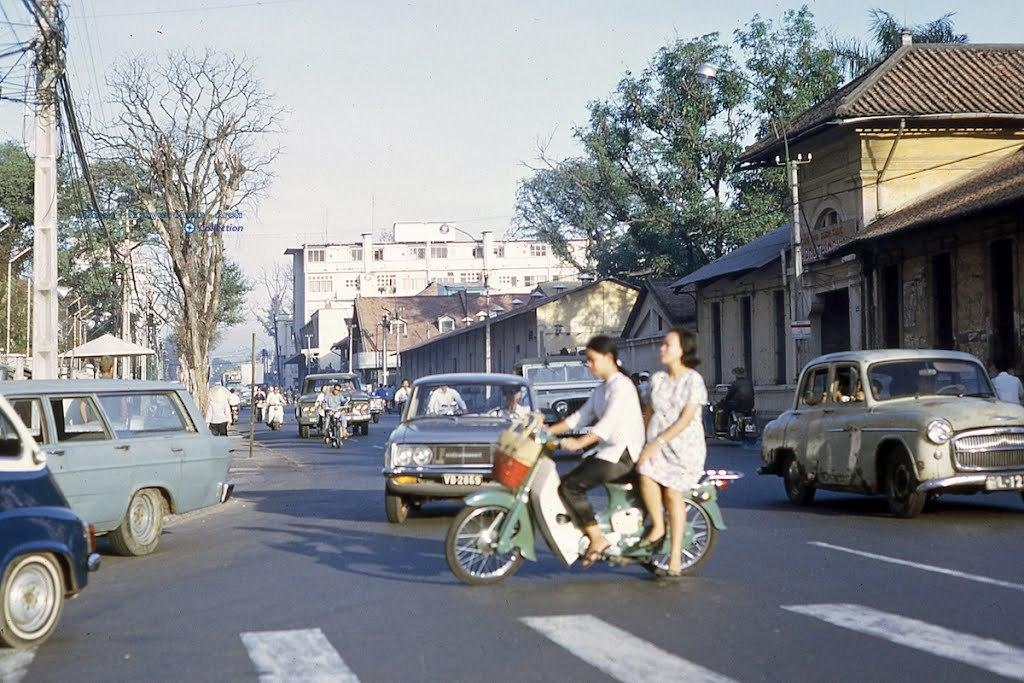What can be seen on the road in the image? There are vehicles on the road in the image. What structures are present in the image? There are buildings in the image. What type of vegetation is visible in the image? There are trees in the image. Can you describe the right corner of the image? In the right corner of the image, there are buildings and trees. How about the left corner of the image? In the left corner of the image, there are poles, wires, and trees. How many dimes can be found in the image? There are no dimes present in the image. What level of comfort can be seen in the image? The image does not depict a level of comfort; it shows vehicles, buildings, trees, poles, and wires. 